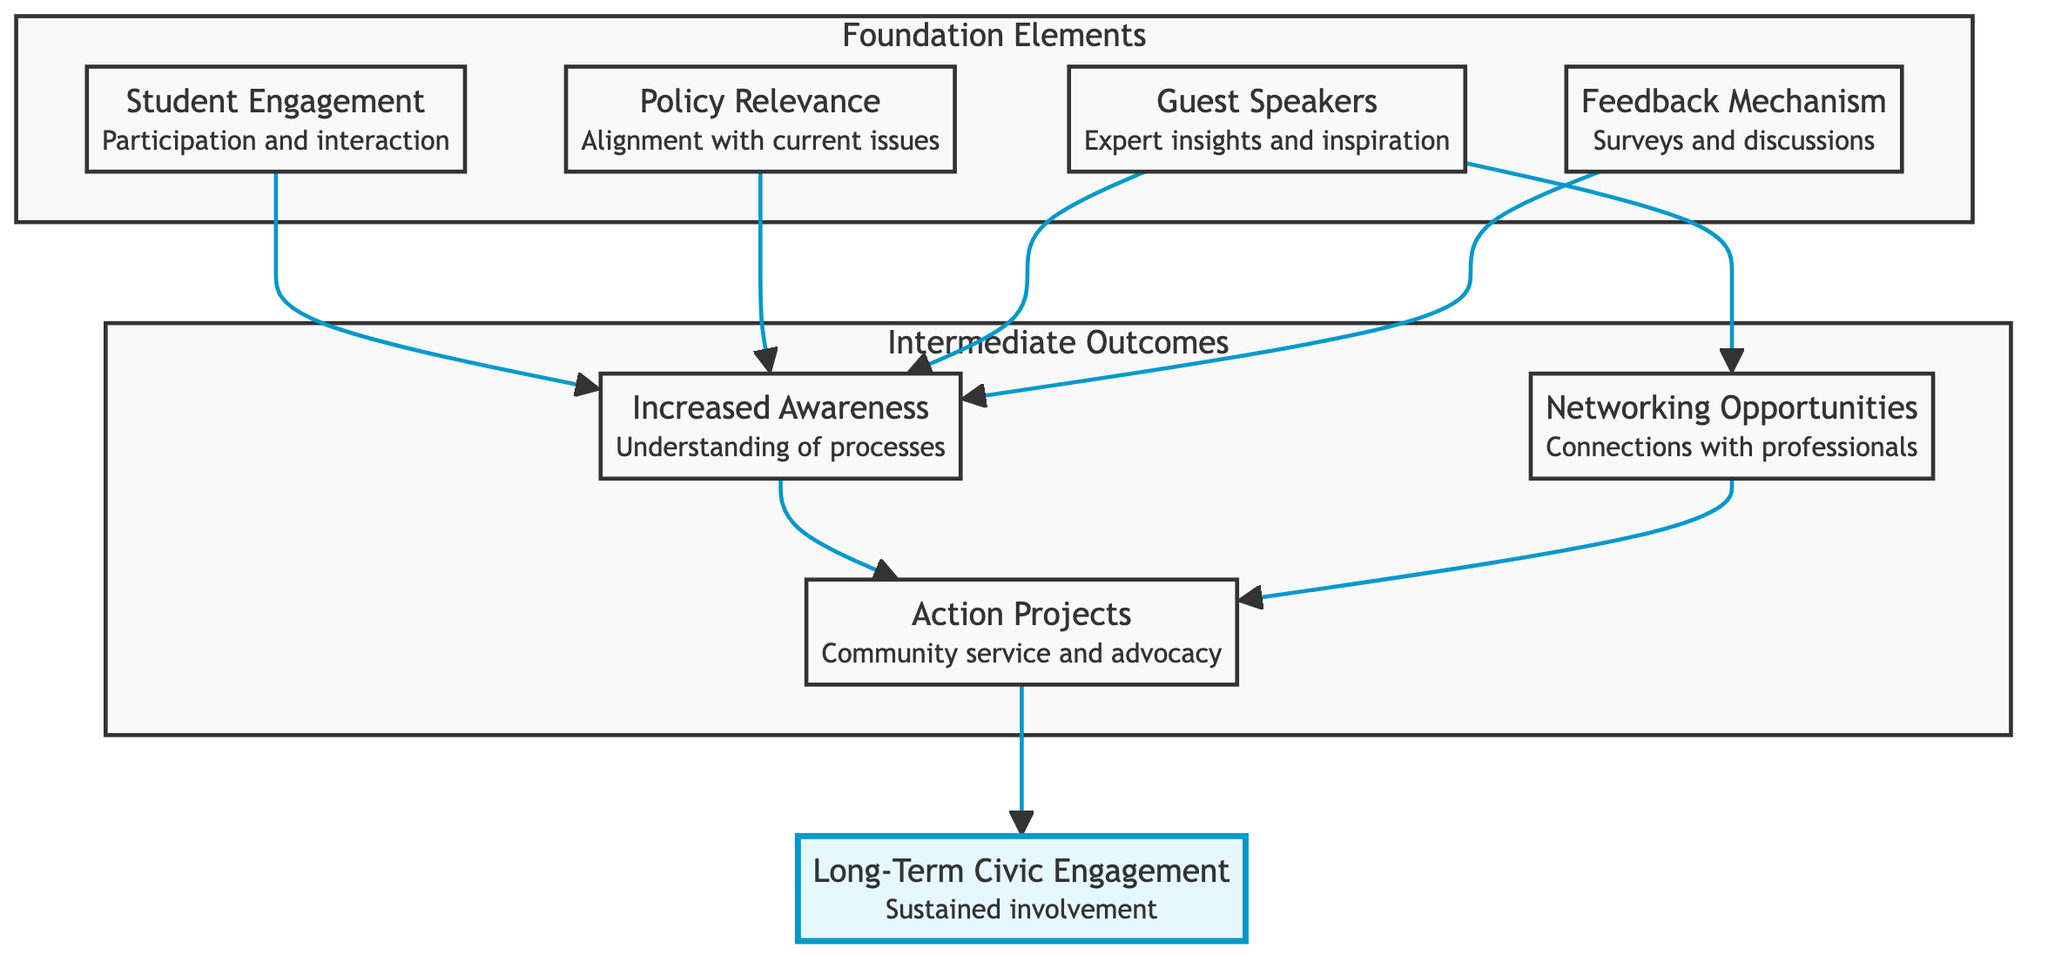What are the four foundation elements in the diagram? The foundation elements are listed in the "Foundation" subgraph, which contains Student Engagement, Policy Relevance, Guest Speakers, and Feedback Mechanism.
Answer: Student Engagement, Policy Relevance, Guest Speakers, Feedback Mechanism How many intermediate outcomes are there in the diagram? The intermediate outcomes listed in the "Intermediate" subgraph include Increased Awareness, Networking Opportunities, and Action Projects, totaling three outcomes.
Answer: 3 Which foundation element directly connects to Increased Awareness? The arrows show that Student Engagement, Policy Relevance, Guest Speakers, and Feedback Mechanism all lead to Increased Awareness; hence, they are all connected. However, since the question requires a singular element, the first listed is Student Engagement.
Answer: Student Engagement What is the final outcome represented in the diagram? The flowchart ends with Long-Term Civic Engagement, which is the last node that results from the connections made through the intermediate outcomes.
Answer: Long-Term Civic Engagement Which nodes contribute to Action Projects? The diagram indicates that Increased Awareness and Networking Opportunities both lead to Action Projects, meaning these two nodes contribute to it.
Answer: Increased Awareness, Networking Opportunities How many connections (edges) are there originating from Guest Speakers? The Guest Speakers node has two connections: one leading to Increased Awareness and another leading to Networking Opportunities, resulting in a total of two outgoing edges.
Answer: 2 What role does the Feedback Mechanism play in student awareness? The Feedback Mechanism directly influences Increased Awareness; it collects structured feedback and is indicated by the connecting arrow to Increased Awareness in the diagram.
Answer: Influences Increased Awareness Name one factor that leads to Long-Term Civic Engagement. The arrows show that Action Projects directly lead to Long-Term Civic Engagement, making it a significant factor contributing to it.
Answer: Action Projects 